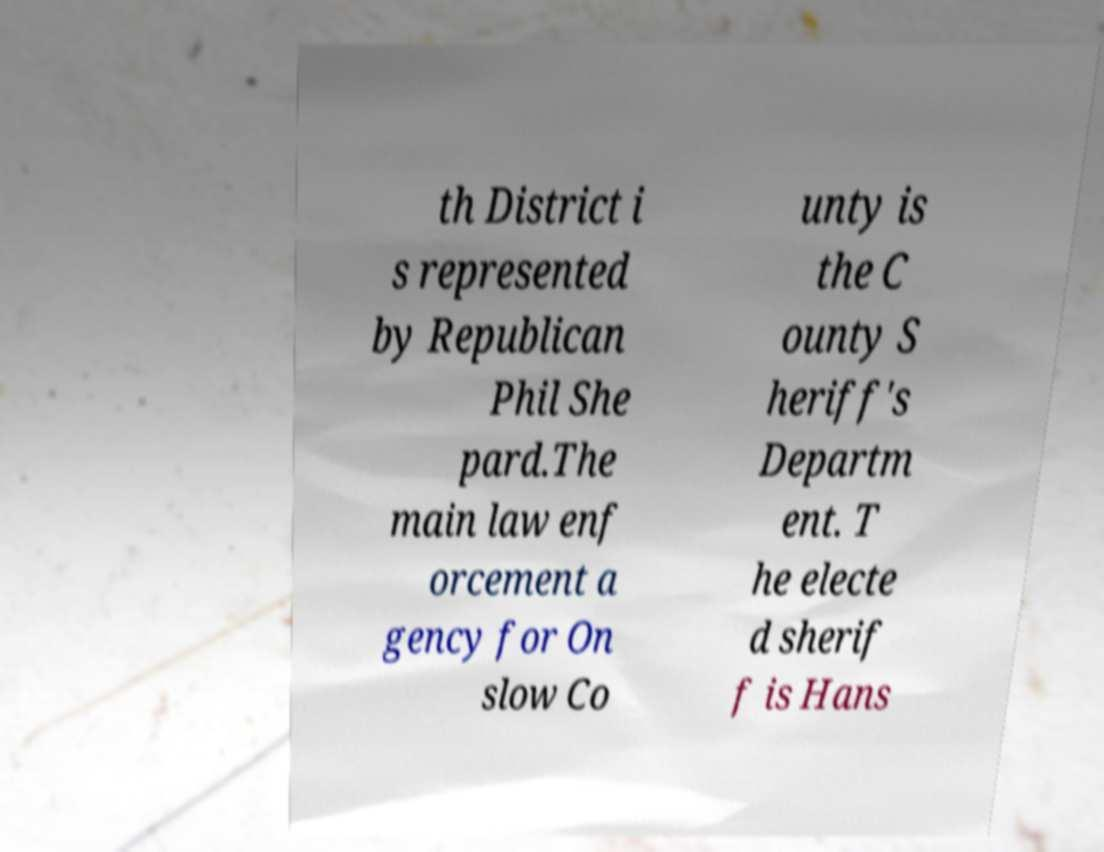Can you read and provide the text displayed in the image?This photo seems to have some interesting text. Can you extract and type it out for me? th District i s represented by Republican Phil She pard.The main law enf orcement a gency for On slow Co unty is the C ounty S heriff's Departm ent. T he electe d sherif f is Hans 